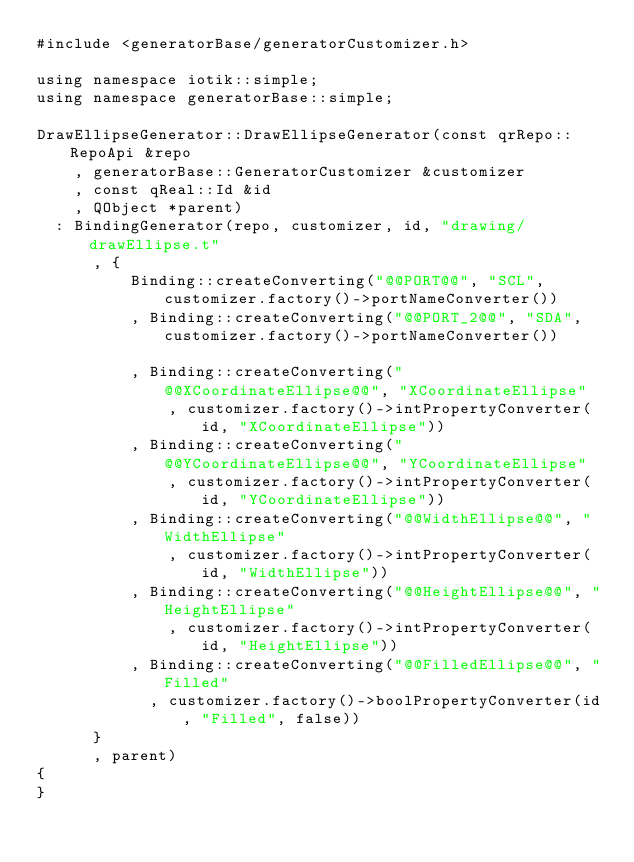Convert code to text. <code><loc_0><loc_0><loc_500><loc_500><_C++_>#include <generatorBase/generatorCustomizer.h>

using namespace iotik::simple;
using namespace generatorBase::simple;

DrawEllipseGenerator::DrawEllipseGenerator(const qrRepo::RepoApi &repo
		, generatorBase::GeneratorCustomizer &customizer
		, const qReal::Id &id
		, QObject *parent)
	: BindingGenerator(repo, customizer, id, "drawing/drawEllipse.t"
			, {
					Binding::createConverting("@@PORT@@", "SCL", customizer.factory()->portNameConverter())
					, Binding::createConverting("@@PORT_2@@", "SDA", customizer.factory()->portNameConverter())

					, Binding::createConverting("@@XCoordinateEllipse@@", "XCoordinateEllipse"
							, customizer.factory()->intPropertyConverter(id, "XCoordinateEllipse"))
					, Binding::createConverting("@@YCoordinateEllipse@@", "YCoordinateEllipse"
							, customizer.factory()->intPropertyConverter(id, "YCoordinateEllipse"))
					, Binding::createConverting("@@WidthEllipse@@", "WidthEllipse"
							, customizer.factory()->intPropertyConverter(id, "WidthEllipse"))
					, Binding::createConverting("@@HeightEllipse@@", "HeightEllipse"
							, customizer.factory()->intPropertyConverter(id, "HeightEllipse"))
					, Binding::createConverting("@@FilledEllipse@@", "Filled"
						, customizer.factory()->boolPropertyConverter(id, "Filled", false))
			}
			, parent)
{
}
</code> 